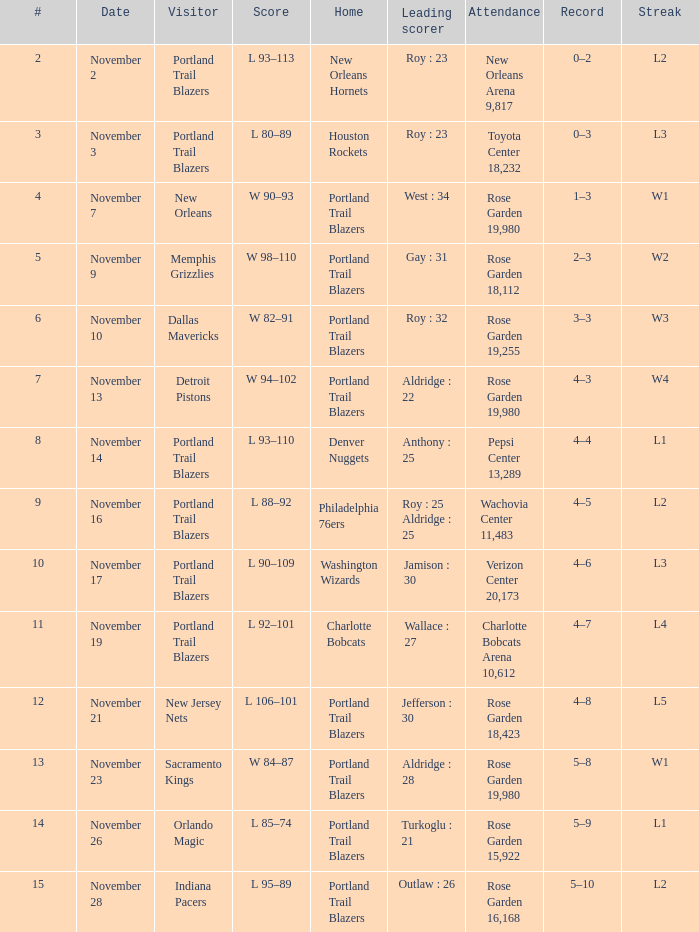Help me parse the entirety of this table. {'header': ['#', 'Date', 'Visitor', 'Score', 'Home', 'Leading scorer', 'Attendance', 'Record', 'Streak'], 'rows': [['2', 'November 2', 'Portland Trail Blazers', 'L 93–113', 'New Orleans Hornets', 'Roy : 23', 'New Orleans Arena 9,817', '0–2', 'L2'], ['3', 'November 3', 'Portland Trail Blazers', 'L 80–89', 'Houston Rockets', 'Roy : 23', 'Toyota Center 18,232', '0–3', 'L3'], ['4', 'November 7', 'New Orleans', 'W 90–93', 'Portland Trail Blazers', 'West : 34', 'Rose Garden 19,980', '1–3', 'W1'], ['5', 'November 9', 'Memphis Grizzlies', 'W 98–110', 'Portland Trail Blazers', 'Gay : 31', 'Rose Garden 18,112', '2–3', 'W2'], ['6', 'November 10', 'Dallas Mavericks', 'W 82–91', 'Portland Trail Blazers', 'Roy : 32', 'Rose Garden 19,255', '3–3', 'W3'], ['7', 'November 13', 'Detroit Pistons', 'W 94–102', 'Portland Trail Blazers', 'Aldridge : 22', 'Rose Garden 19,980', '4–3', 'W4'], ['8', 'November 14', 'Portland Trail Blazers', 'L 93–110', 'Denver Nuggets', 'Anthony : 25', 'Pepsi Center 13,289', '4–4', 'L1'], ['9', 'November 16', 'Portland Trail Blazers', 'L 88–92', 'Philadelphia 76ers', 'Roy : 25 Aldridge : 25', 'Wachovia Center 11,483', '4–5', 'L2'], ['10', 'November 17', 'Portland Trail Blazers', 'L 90–109', 'Washington Wizards', 'Jamison : 30', 'Verizon Center 20,173', '4–6', 'L3'], ['11', 'November 19', 'Portland Trail Blazers', 'L 92–101', 'Charlotte Bobcats', 'Wallace : 27', 'Charlotte Bobcats Arena 10,612', '4–7', 'L4'], ['12', 'November 21', 'New Jersey Nets', 'L 106–101', 'Portland Trail Blazers', 'Jefferson : 30', 'Rose Garden 18,423', '4–8', 'L5'], ['13', 'November 23', 'Sacramento Kings', 'W 84–87', 'Portland Trail Blazers', 'Aldridge : 28', 'Rose Garden 19,980', '5–8', 'W1'], ['14', 'November 26', 'Orlando Magic', 'L 85–74', 'Portland Trail Blazers', 'Turkoglu : 21', 'Rose Garden 15,922', '5–9', 'L1'], ['15', 'November 28', 'Indiana Pacers', 'L 95–89', 'Portland Trail Blazers', 'Outlaw : 26', 'Rose Garden 16,168', '5–10', 'L2']]} In which home team is the leading scorer roy with 23 points and currently on an l3 streak? Houston Rockets. 